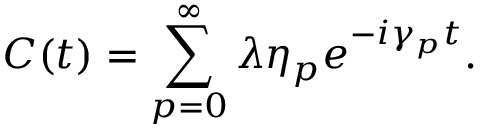Convert formula to latex. <formula><loc_0><loc_0><loc_500><loc_500>C ( t ) = \sum _ { p = 0 } ^ { \infty } \lambda \eta _ { p } e ^ { - i \gamma _ { p } t } .</formula> 